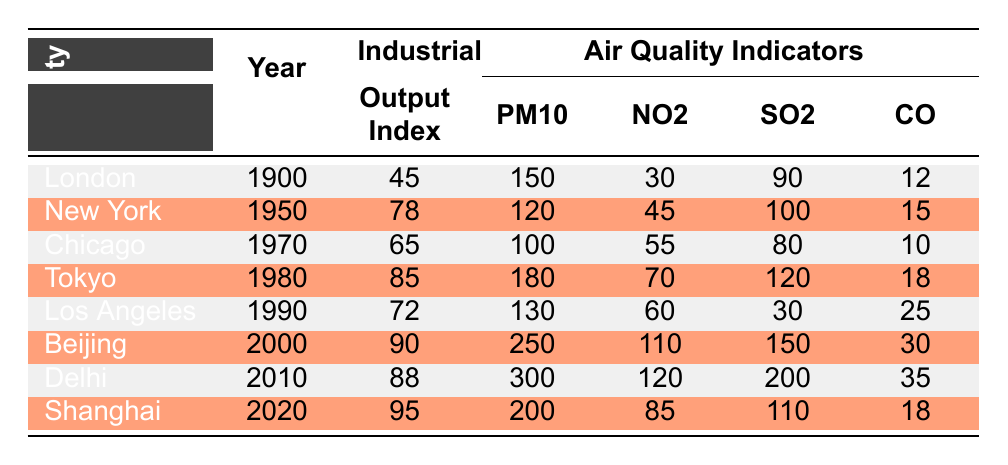What is the PM10 level in Delhi in 2010? The table lists the PM10 level for Delhi under the column for air quality indicators in the year 2010, which is 300.
Answer: 300 Which city had the highest SO2 level and what was it? By comparing the SO2 levels across all cities on the table, Delhi in 2010 has the highest SO2 level at 200.
Answer: 200 What is the average Industrial Output Index for all cities listed? To find the average, sum up the Industrial Output Index values (45 + 78 + 65 + 85 + 72 + 90 + 88 + 95 = 723) and divide by the number of cities (8). The average is 723/8 = 90.375.
Answer: 90.375 Did Chicago in 1970 have a higher NO2 level than New York in 1950? From the table, Chicago's NO2 level in 1970 is 55, while New York's is 45. Therefore, Chicago had a higher NO2 level than New York.
Answer: Yes Which two cities experienced an increase in PM10 from one measurement to the next and which years are they? By examining the PM10 levels across subsequent years, we see Delhi (2010) at 300 and Beijing (2000) at 250; Delhi’s earlier reading is not available, but Beijing went from 250 (2000) to 300 (2010) for Delhi, confirming an increase from 250 to 300, emphasizing the trajectory. The answer broadly reflects Delhi and Beijing due to their notable increases.
Answer: Delhi and Beijing What is the percentage increase in PM10 from Chicago in 1970 to Beijing in 2000? Chicago's PM10 level in 1970 is 100 and Beijing's in 2000 is 250. First, calculate the increase: 250-100 = 150. Then, the percentage increase is (150/100) * 100 = 150%.
Answer: 150% What were the CO levels for Los Angeles in 1990 and Tokyo in 1980, and which city had a higher level? The CO level for Los Angeles in 1990 is 25 and for Tokyo in 1980 is 18. Since 25 is greater than 18, Los Angeles had a higher CO level.
Answer: Los Angeles had a higher level Is the Industrial Output Index for Shanghai in 2020 higher than that of Tokyo in 1980? The index for Shanghai in 2020 is 95 and for Tokyo in 1980 it is 85. Since 95 is greater than 85, the statement is true.
Answer: Yes What is the trend in Industrial Output Index from London in 1900 to Delhi in 2010? The Industrial Output Index shows values increasing from 45 (London, 1900) to 88 (Delhi, 2010) showing a clear upward trend in industrial output consistently over the time span of 110 years.
Answer: Increasing trend 